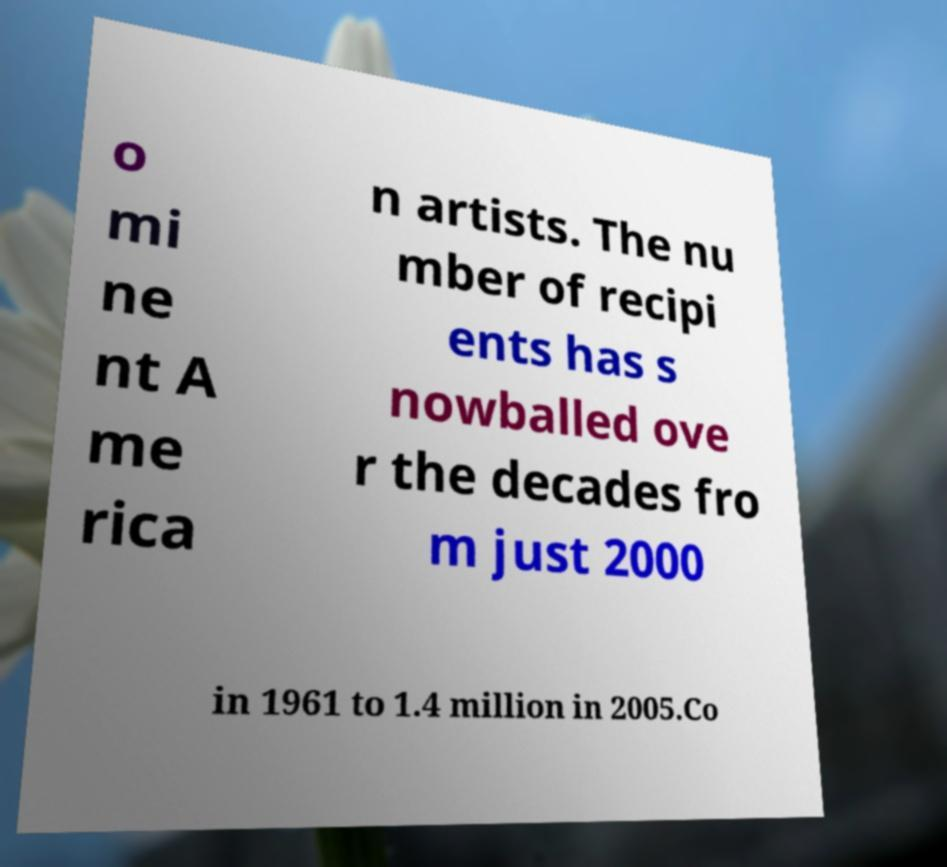What messages or text are displayed in this image? I need them in a readable, typed format. o mi ne nt A me rica n artists. The nu mber of recipi ents has s nowballed ove r the decades fro m just 2000 in 1961 to 1.4 million in 2005.Co 